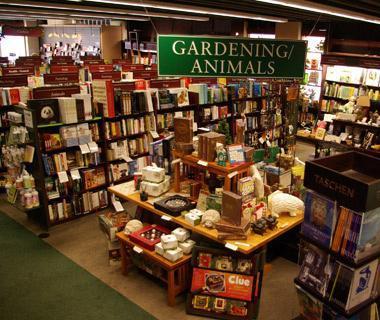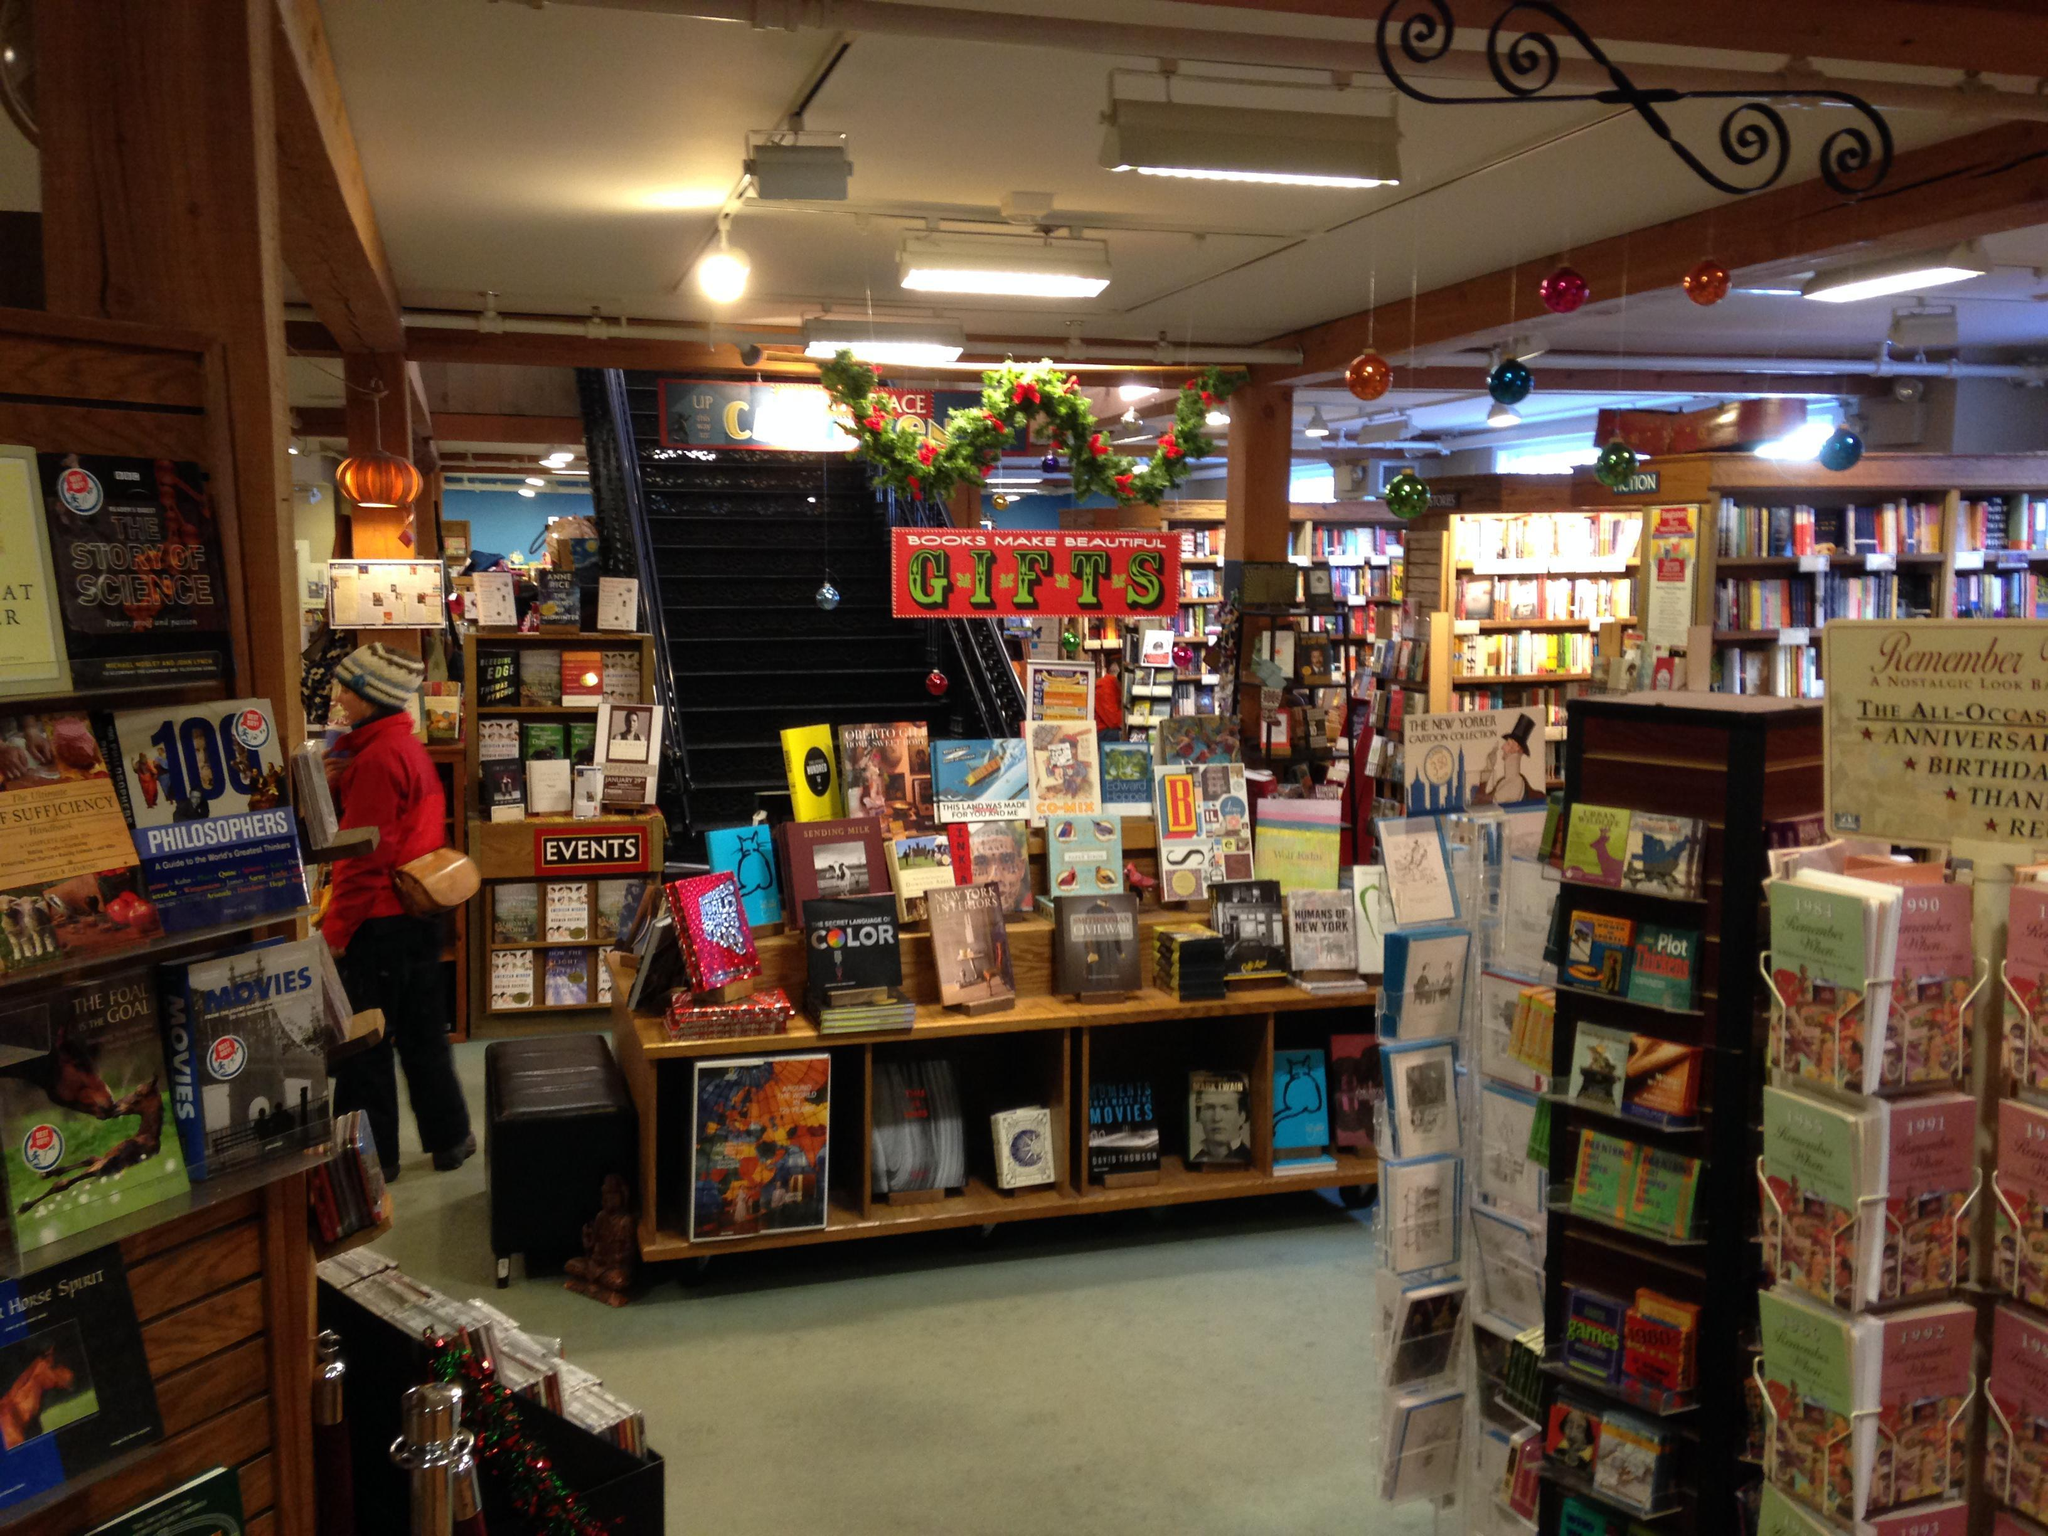The first image is the image on the left, the second image is the image on the right. Assess this claim about the two images: "The left image shows a bookstore with a second floor of bookshelves surrounded by balcony rails.". Correct or not? Answer yes or no. No. The first image is the image on the left, the second image is the image on the right. For the images shown, is this caption "There is a stairway visible in one of the images." true? Answer yes or no. No. 